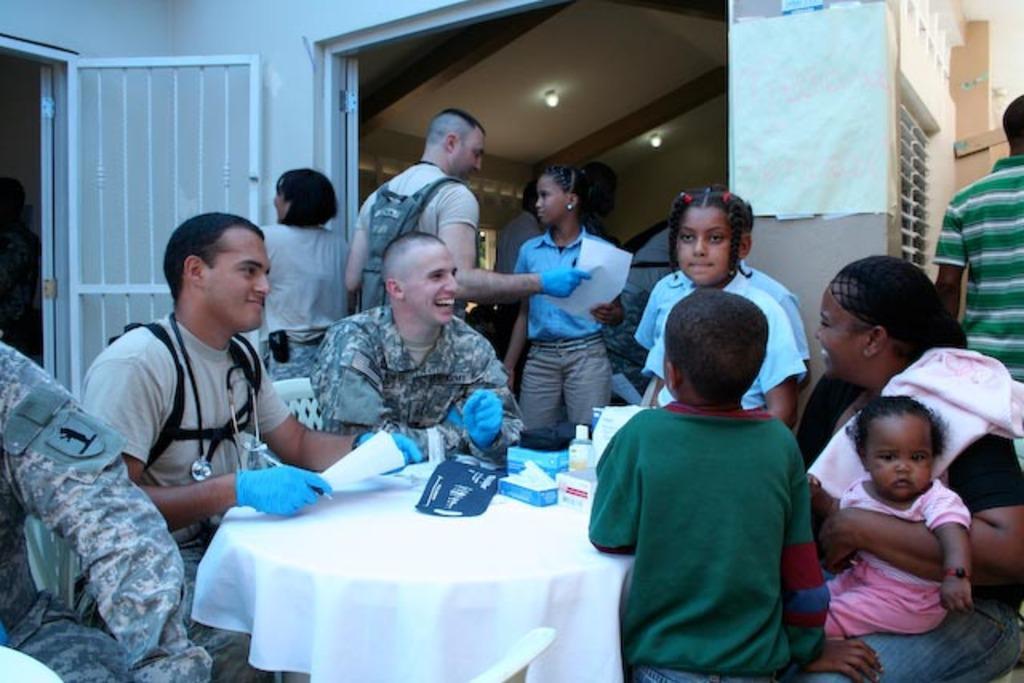In one or two sentences, can you explain what this image depicts? In this picture we can see some persons are sitting on the chairs. And this is the table. On the table there is a white color cloth, bottle, and some boxes. And even we can see some persons are standing on the floor. This is the door. And there is a wall and these are the lights. 